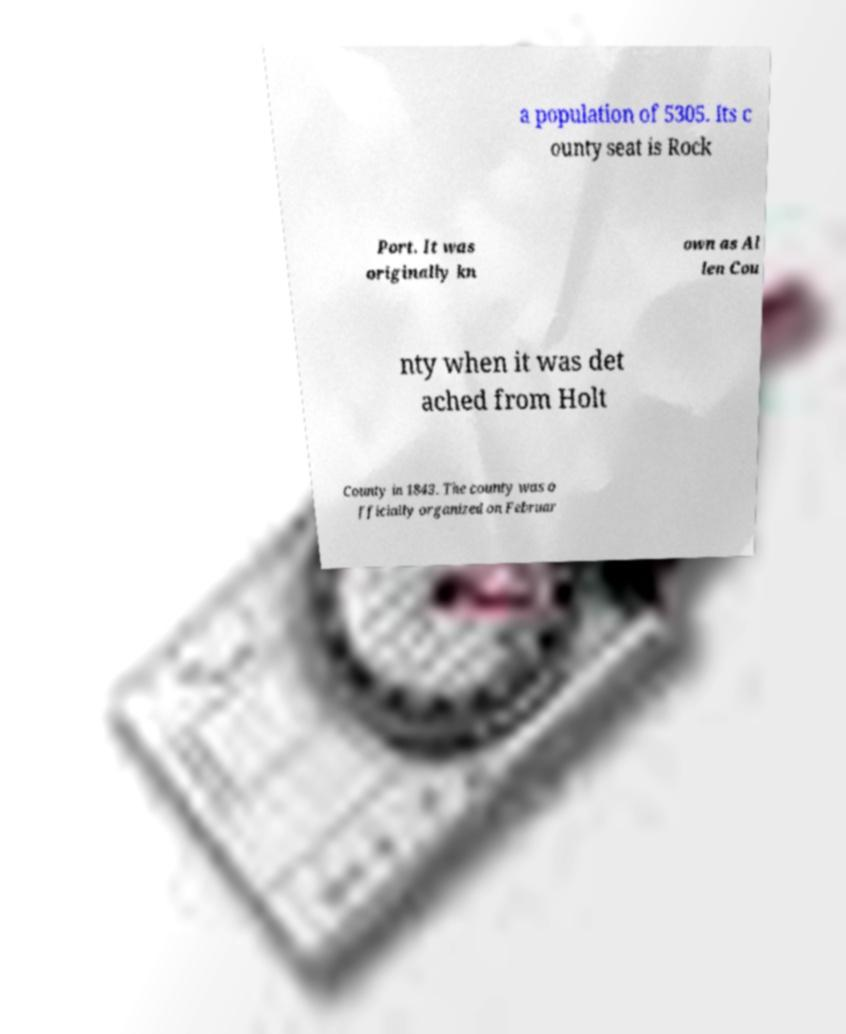What messages or text are displayed in this image? I need them in a readable, typed format. a population of 5305. Its c ounty seat is Rock Port. It was originally kn own as Al len Cou nty when it was det ached from Holt County in 1843. The county was o fficially organized on Februar 